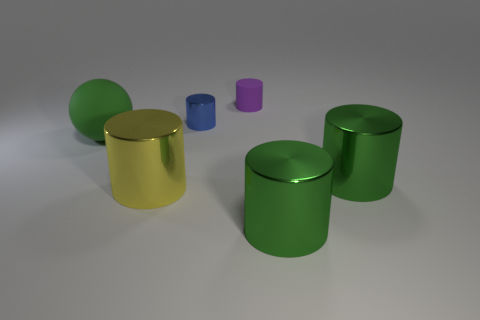Is there any other thing that has the same shape as the green rubber thing?
Your answer should be very brief. No. There is a purple object that is the same shape as the big yellow object; what is its size?
Offer a terse response. Small. What is the shape of the blue object?
Ensure brevity in your answer.  Cylinder. There is a green thing that is left of the blue cylinder; does it have the same size as the yellow cylinder?
Provide a short and direct response. Yes. Is there a small blue object that has the same material as the big ball?
Your answer should be very brief. No. What number of things are either large green metallic cylinders to the right of the big green rubber sphere or metal cylinders?
Give a very brief answer. 4. Are there any tiny yellow matte cylinders?
Provide a succinct answer. No. What is the shape of the big object that is both behind the big yellow metallic cylinder and to the left of the purple rubber cylinder?
Ensure brevity in your answer.  Sphere. There is a matte object right of the small metallic object; what size is it?
Keep it short and to the point. Small. There is a cylinder in front of the large yellow object; does it have the same color as the rubber cylinder?
Your response must be concise. No. 